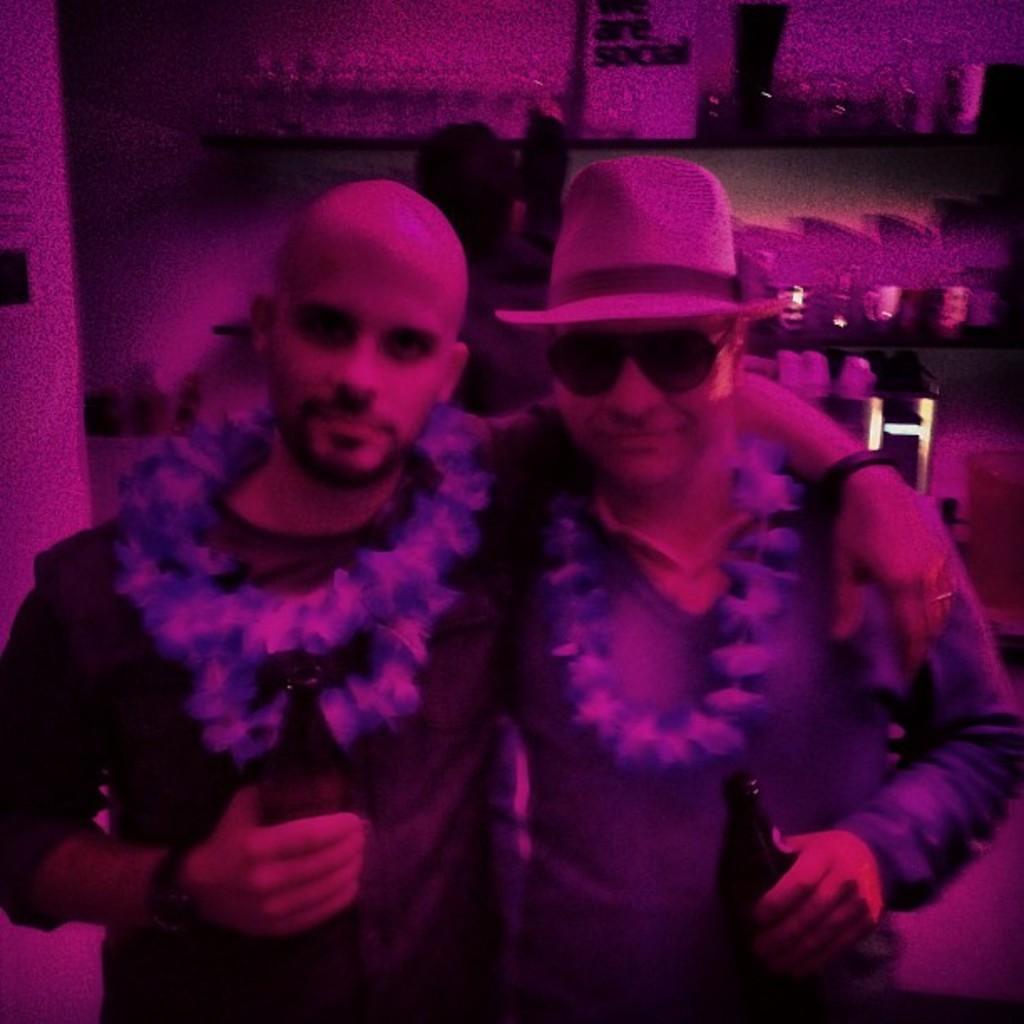Describe this image in one or two sentences. In this picture we can see two men, they are holding bottles, and the right side person wore a cap and spectacles. 